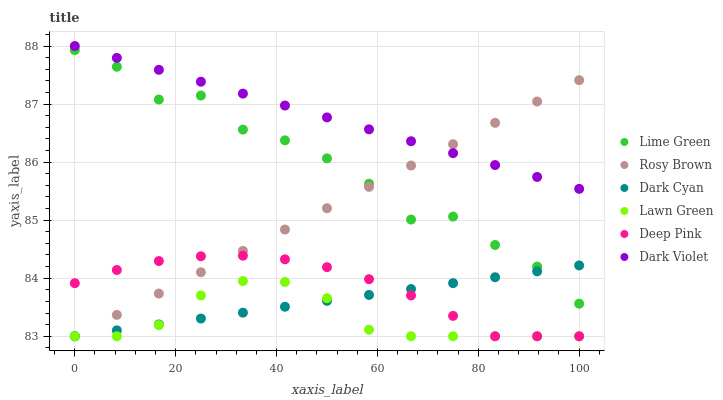Does Lawn Green have the minimum area under the curve?
Answer yes or no. Yes. Does Dark Violet have the maximum area under the curve?
Answer yes or no. Yes. Does Deep Pink have the minimum area under the curve?
Answer yes or no. No. Does Deep Pink have the maximum area under the curve?
Answer yes or no. No. Is Dark Cyan the smoothest?
Answer yes or no. Yes. Is Lime Green the roughest?
Answer yes or no. Yes. Is Deep Pink the smoothest?
Answer yes or no. No. Is Deep Pink the roughest?
Answer yes or no. No. Does Lawn Green have the lowest value?
Answer yes or no. Yes. Does Dark Violet have the lowest value?
Answer yes or no. No. Does Dark Violet have the highest value?
Answer yes or no. Yes. Does Deep Pink have the highest value?
Answer yes or no. No. Is Lawn Green less than Dark Violet?
Answer yes or no. Yes. Is Lime Green greater than Lawn Green?
Answer yes or no. Yes. Does Rosy Brown intersect Lawn Green?
Answer yes or no. Yes. Is Rosy Brown less than Lawn Green?
Answer yes or no. No. Is Rosy Brown greater than Lawn Green?
Answer yes or no. No. Does Lawn Green intersect Dark Violet?
Answer yes or no. No. 